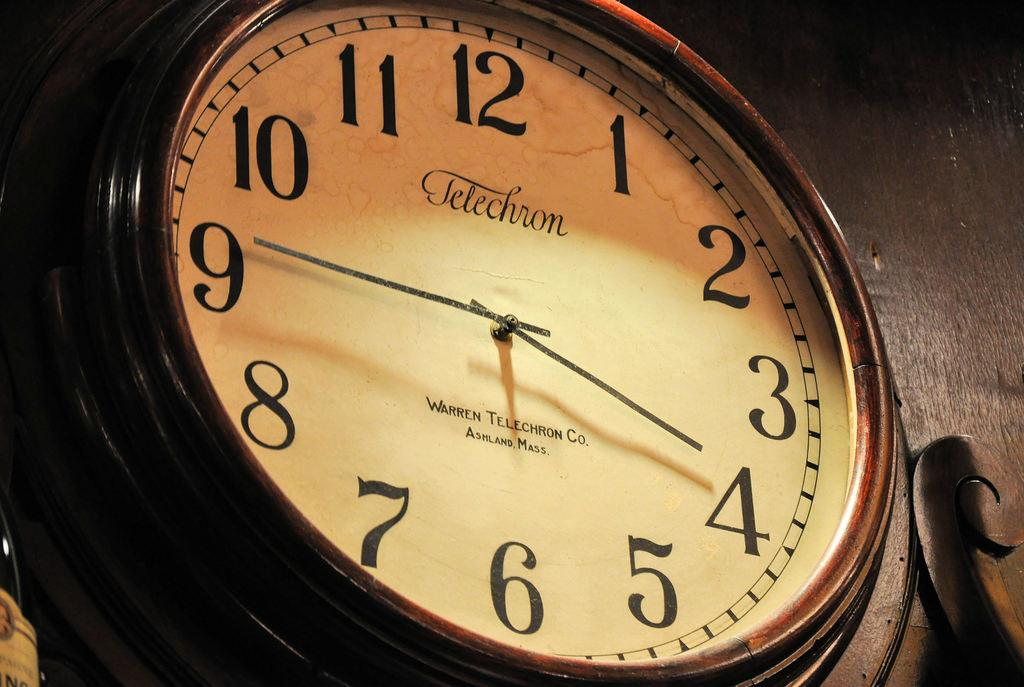<image>
Offer a succinct explanation of the picture presented. A close up of a Telechron black clock. 